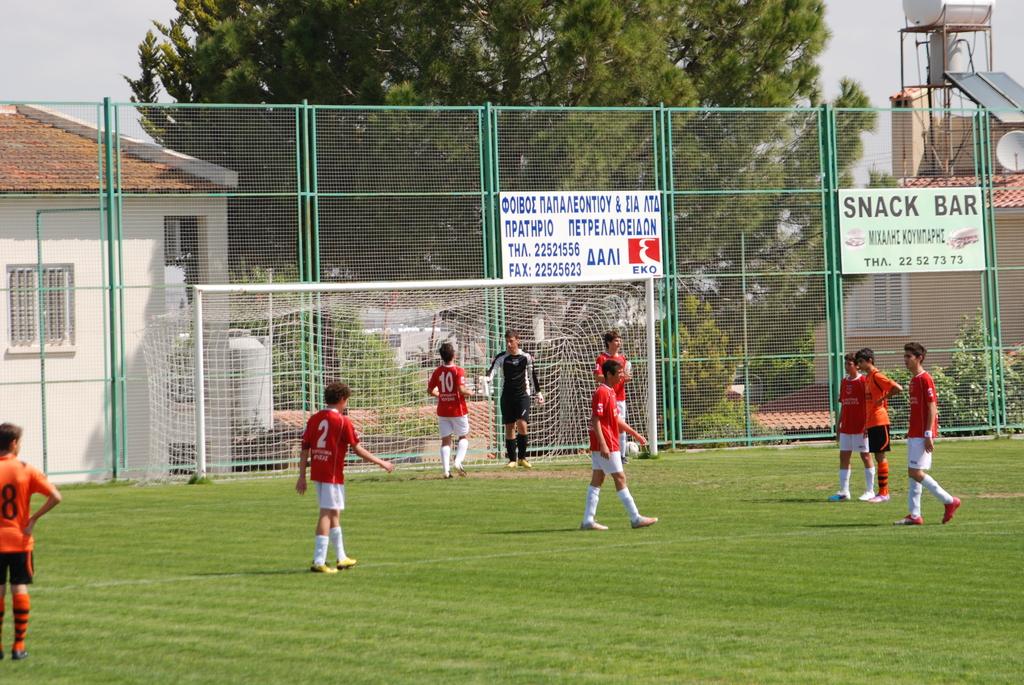What kind of bar is available?
Your answer should be compact. Snack. 